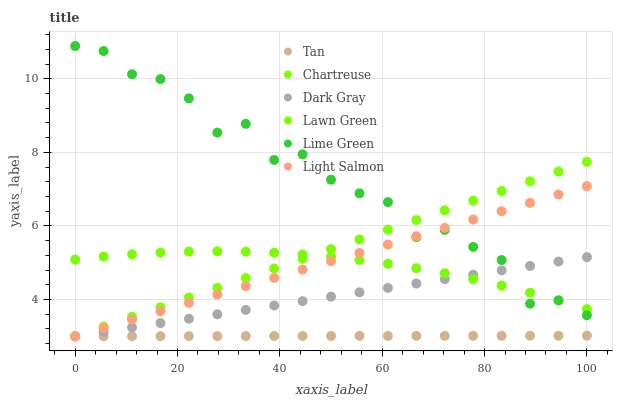Does Tan have the minimum area under the curve?
Answer yes or no. Yes. Does Lime Green have the maximum area under the curve?
Answer yes or no. Yes. Does Light Salmon have the minimum area under the curve?
Answer yes or no. No. Does Light Salmon have the maximum area under the curve?
Answer yes or no. No. Is Tan the smoothest?
Answer yes or no. Yes. Is Lime Green the roughest?
Answer yes or no. Yes. Is Light Salmon the smoothest?
Answer yes or no. No. Is Light Salmon the roughest?
Answer yes or no. No. Does Light Salmon have the lowest value?
Answer yes or no. Yes. Does Lime Green have the lowest value?
Answer yes or no. No. Does Lime Green have the highest value?
Answer yes or no. Yes. Does Light Salmon have the highest value?
Answer yes or no. No. Is Tan less than Lime Green?
Answer yes or no. Yes. Is Lime Green greater than Tan?
Answer yes or no. Yes. Does Dark Gray intersect Chartreuse?
Answer yes or no. Yes. Is Dark Gray less than Chartreuse?
Answer yes or no. No. Is Dark Gray greater than Chartreuse?
Answer yes or no. No. Does Tan intersect Lime Green?
Answer yes or no. No. 